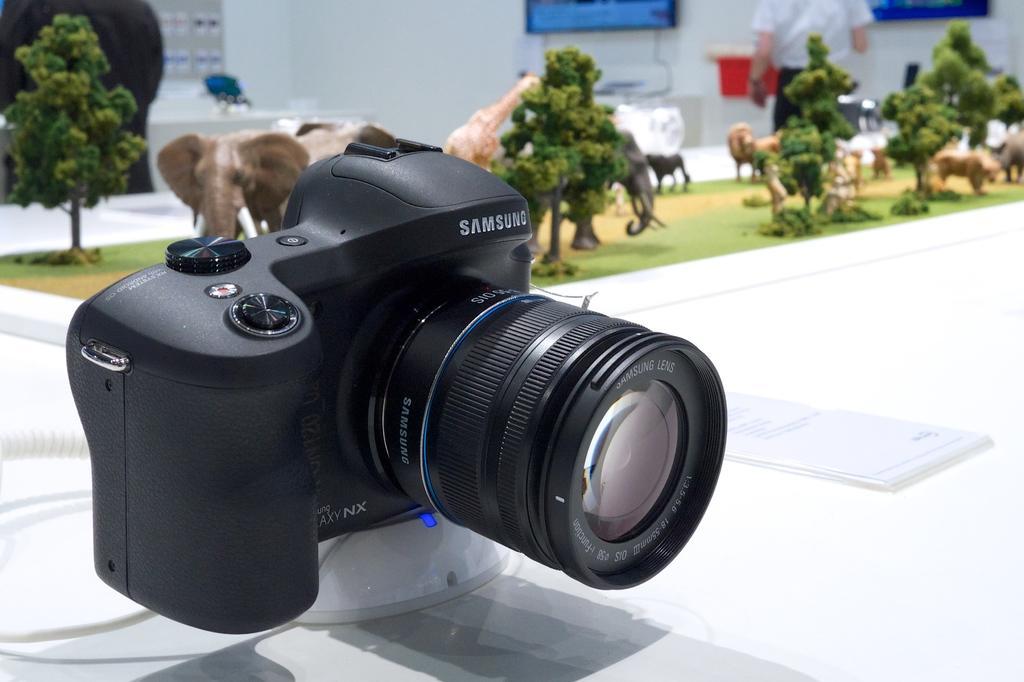Describe this image in one or two sentences. In this picture, we can see a camera on an object, we can see some toys of animals, plants, trees, and we can see the blurred background with a person and the wall. 